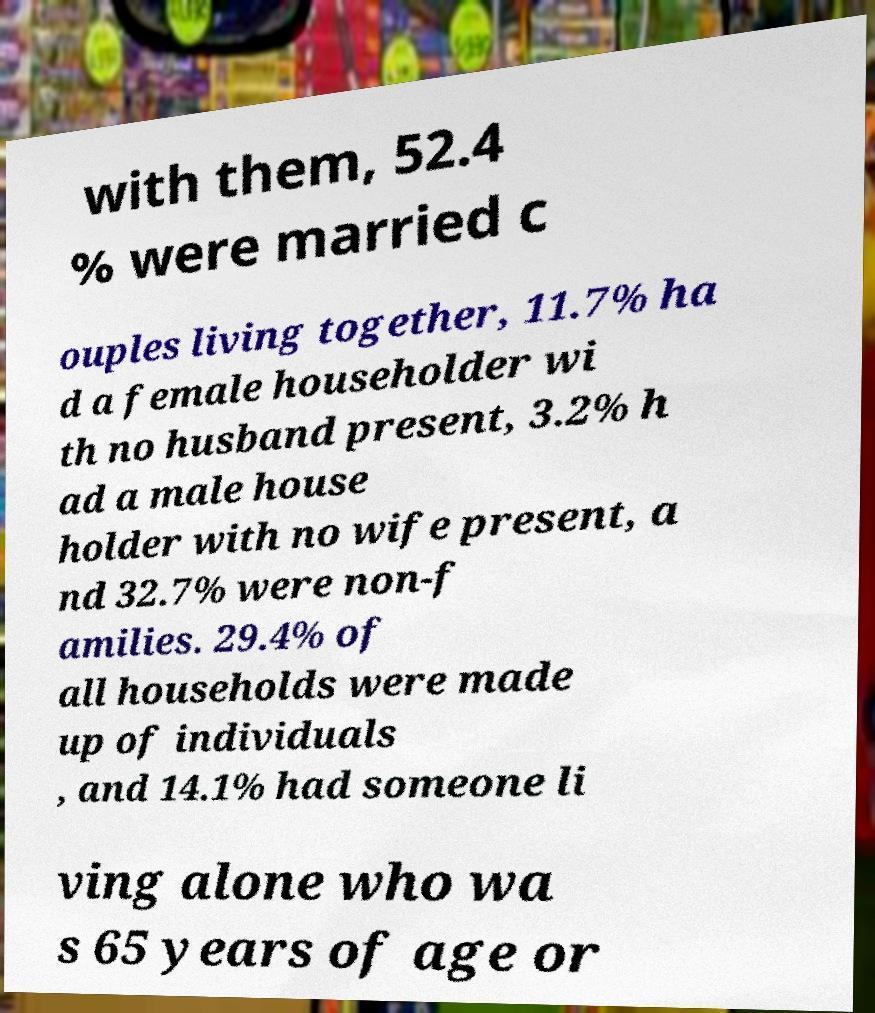Can you accurately transcribe the text from the provided image for me? with them, 52.4 % were married c ouples living together, 11.7% ha d a female householder wi th no husband present, 3.2% h ad a male house holder with no wife present, a nd 32.7% were non-f amilies. 29.4% of all households were made up of individuals , and 14.1% had someone li ving alone who wa s 65 years of age or 